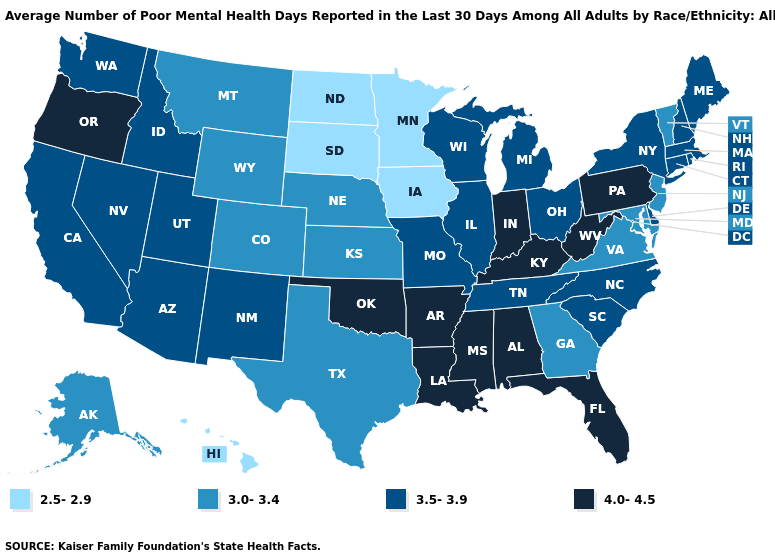What is the value of Utah?
Give a very brief answer. 3.5-3.9. Which states hav the highest value in the West?
Answer briefly. Oregon. What is the value of New Hampshire?
Short answer required. 3.5-3.9. What is the lowest value in the USA?
Keep it brief. 2.5-2.9. Does the first symbol in the legend represent the smallest category?
Keep it brief. Yes. Which states have the highest value in the USA?
Keep it brief. Alabama, Arkansas, Florida, Indiana, Kentucky, Louisiana, Mississippi, Oklahoma, Oregon, Pennsylvania, West Virginia. What is the value of Arizona?
Keep it brief. 3.5-3.9. Does California have a lower value than West Virginia?
Write a very short answer. Yes. Name the states that have a value in the range 2.5-2.9?
Give a very brief answer. Hawaii, Iowa, Minnesota, North Dakota, South Dakota. Name the states that have a value in the range 2.5-2.9?
Quick response, please. Hawaii, Iowa, Minnesota, North Dakota, South Dakota. Is the legend a continuous bar?
Write a very short answer. No. What is the value of Oklahoma?
Keep it brief. 4.0-4.5. Among the states that border Missouri , does Kentucky have the lowest value?
Concise answer only. No. What is the value of Rhode Island?
Short answer required. 3.5-3.9. Does Indiana have the highest value in the MidWest?
Be succinct. Yes. 